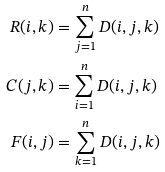Convert formula to latex. <formula><loc_0><loc_0><loc_500><loc_500>R ( i , k ) & = \sum _ { j = 1 } ^ { n } D ( i , j , k ) \\ C ( j , k ) & = \sum _ { i = 1 } ^ { n } D ( i , j , k ) \\ F ( i , j ) & = \sum _ { k = 1 } ^ { n } D ( i , j , k )</formula> 